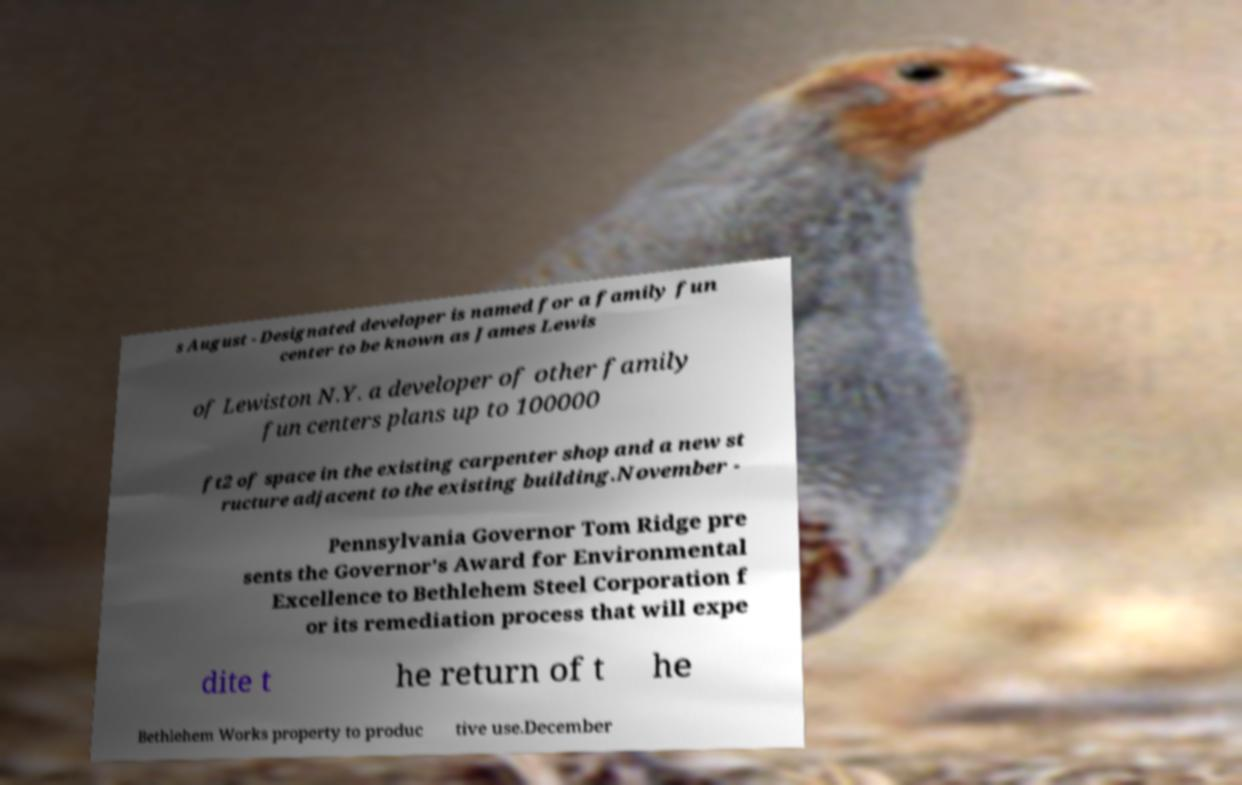There's text embedded in this image that I need extracted. Can you transcribe it verbatim? s August - Designated developer is named for a family fun center to be known as James Lewis of Lewiston N.Y. a developer of other family fun centers plans up to 100000 ft2 of space in the existing carpenter shop and a new st ructure adjacent to the existing building.November - Pennsylvania Governor Tom Ridge pre sents the Governor's Award for Environmental Excellence to Bethlehem Steel Corporation f or its remediation process that will expe dite t he return of t he Bethlehem Works property to produc tive use.December 